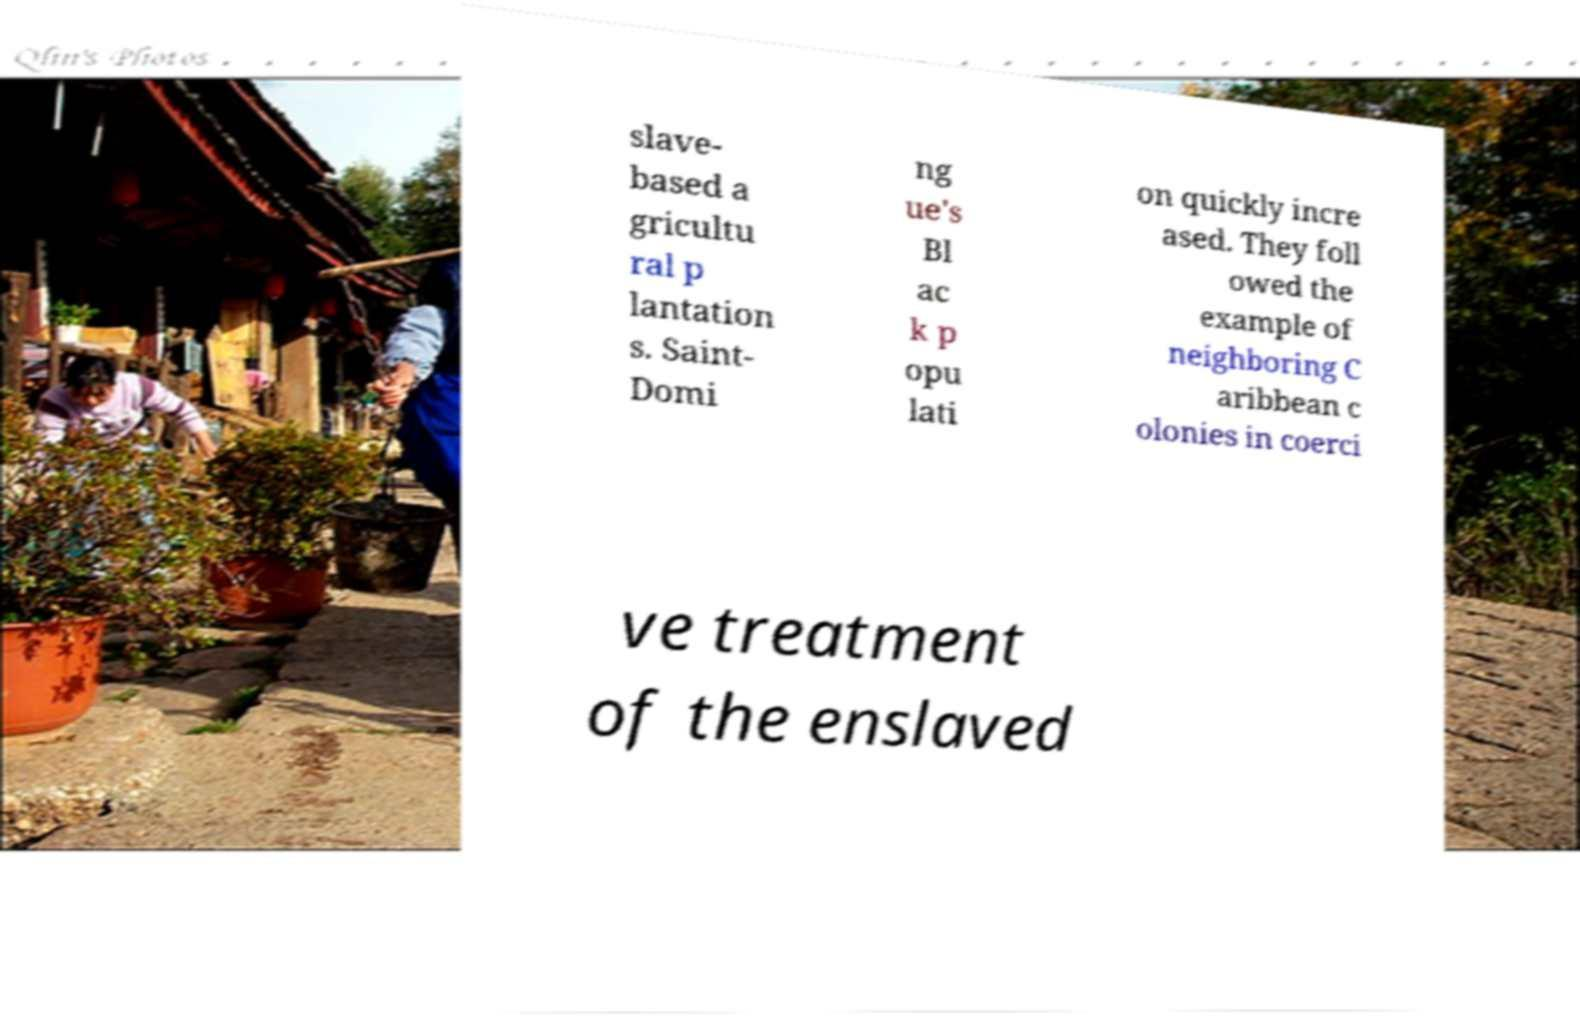Could you extract and type out the text from this image? slave- based a gricultu ral p lantation s. Saint- Domi ng ue's Bl ac k p opu lati on quickly incre ased. They foll owed the example of neighboring C aribbean c olonies in coerci ve treatment of the enslaved 